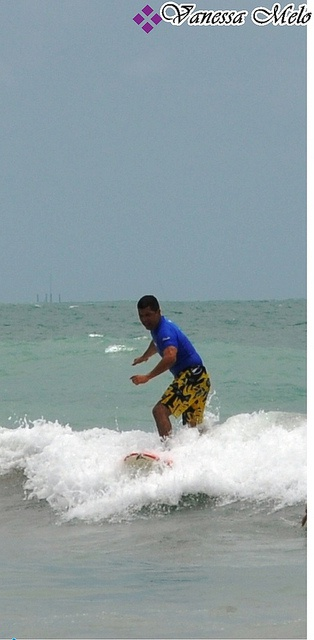Describe the objects in this image and their specific colors. I can see people in darkgray, black, maroon, olive, and navy tones, surfboard in darkgray, lightgray, and gray tones, and surfboard in darkgray, lightgray, pink, and brown tones in this image. 